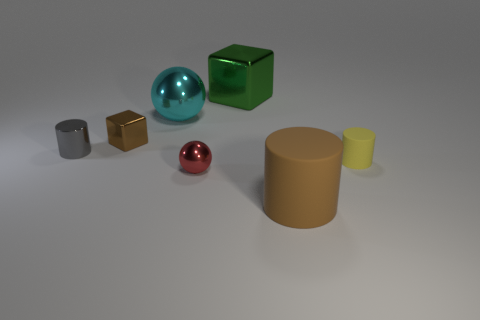How many large rubber cylinders have the same color as the small block?
Offer a terse response. 1. There is a cylinder that is the same color as the tiny block; what is it made of?
Give a very brief answer. Rubber. Are there any big blue cylinders made of the same material as the big ball?
Your answer should be very brief. No. What material is the yellow object that is the same size as the red ball?
Your response must be concise. Rubber. What is the size of the matte cylinder that is in front of the small cylinder that is on the right side of the large matte object in front of the red shiny sphere?
Make the answer very short. Large. Are there any large things that are on the left side of the rubber cylinder that is left of the tiny matte cylinder?
Provide a succinct answer. Yes. There is a small red thing; is it the same shape as the rubber object in front of the tiny yellow cylinder?
Provide a short and direct response. No. What is the color of the small cylinder that is right of the gray metal object?
Give a very brief answer. Yellow. How big is the brown metallic object left of the cyan shiny object that is on the left side of the yellow thing?
Make the answer very short. Small. Does the big thing in front of the small yellow rubber cylinder have the same shape as the brown metallic object?
Ensure brevity in your answer.  No. 